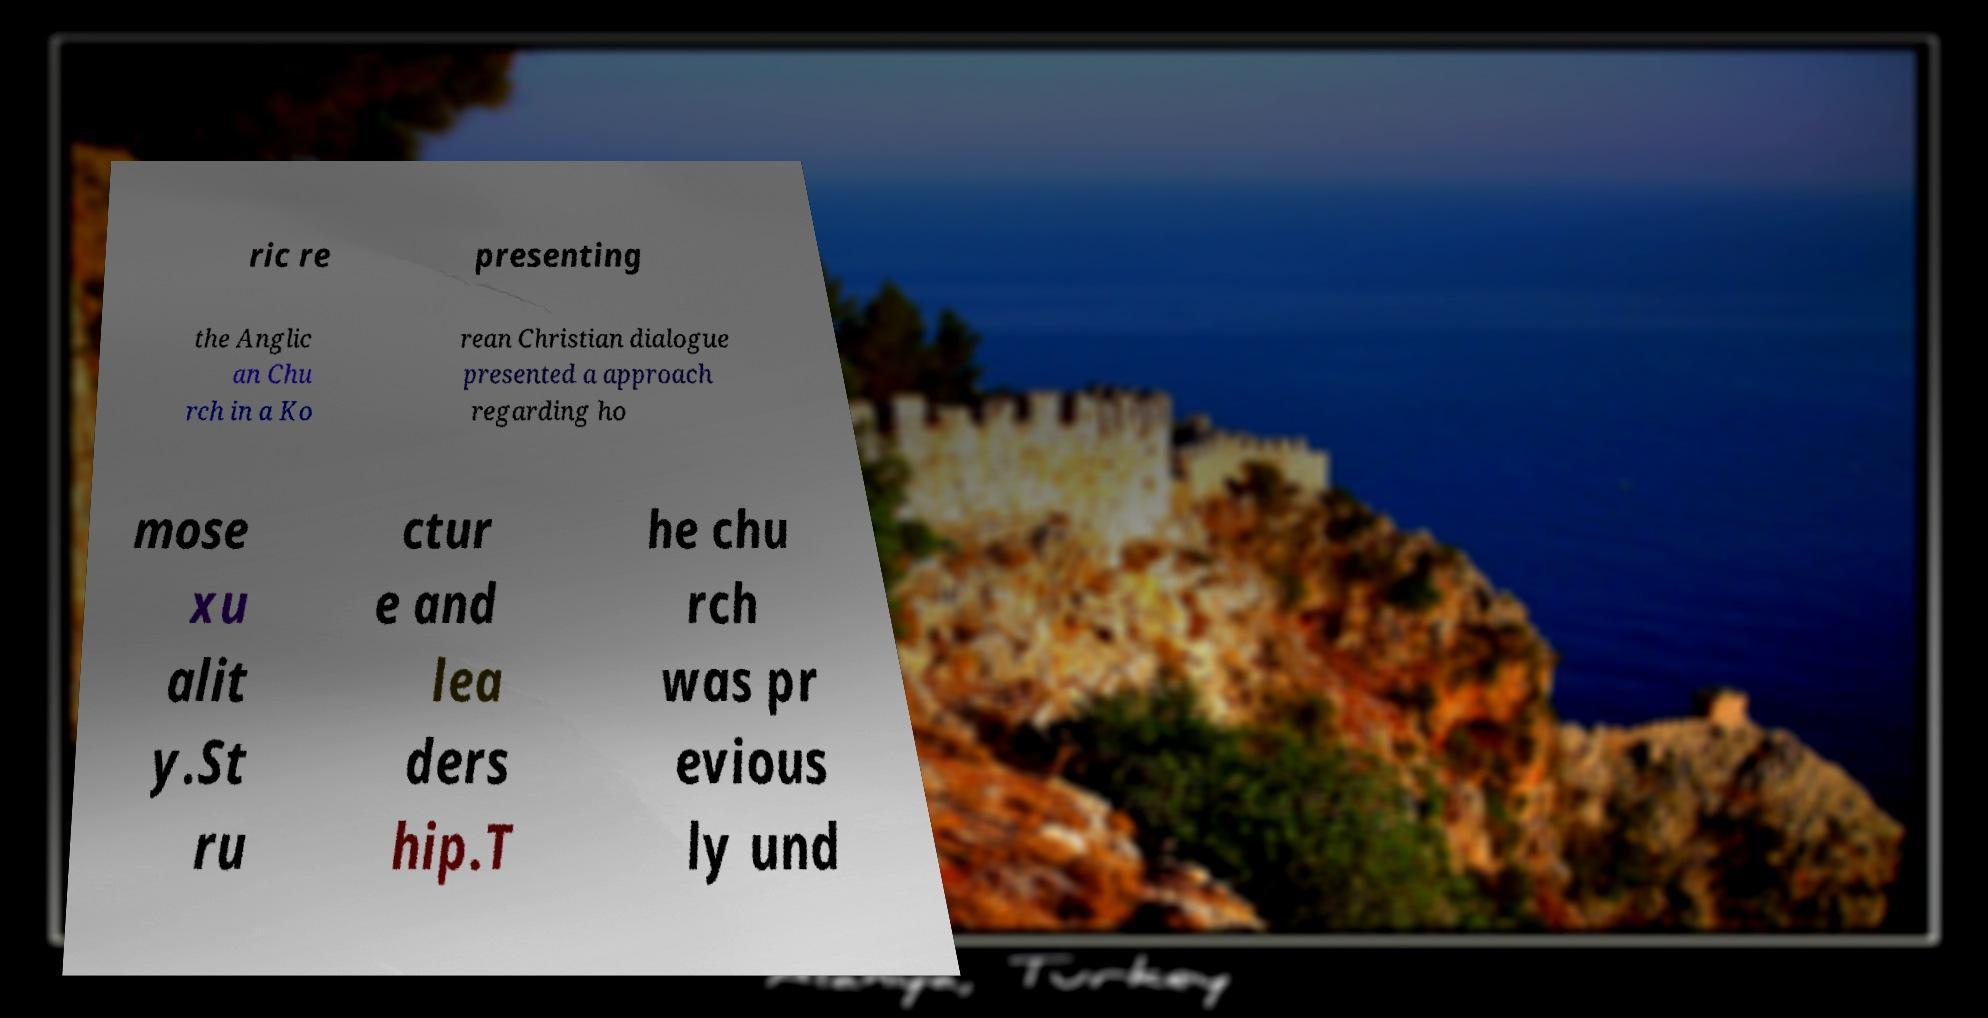Please read and relay the text visible in this image. What does it say? ric re presenting the Anglic an Chu rch in a Ko rean Christian dialogue presented a approach regarding ho mose xu alit y.St ru ctur e and lea ders hip.T he chu rch was pr evious ly und 